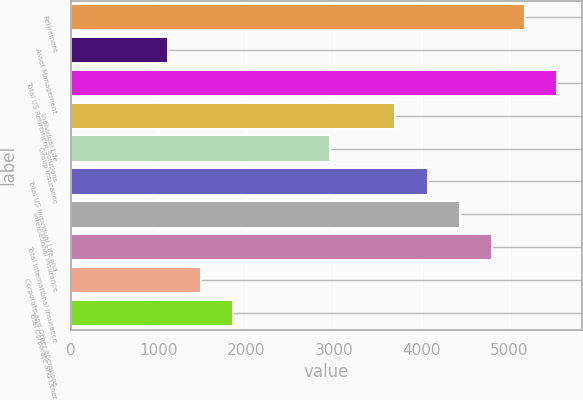<chart> <loc_0><loc_0><loc_500><loc_500><bar_chart><fcel>Retirement<fcel>Asset Management<fcel>Total US Retirement Solutions<fcel>Individual Life<fcel>Group Insurance<fcel>Total US Individual Life and<fcel>International Insurance<fcel>Total International Insurance<fcel>Corporate and Other operations<fcel>Total Corporate and Other<nl><fcel>5182.48<fcel>1111.27<fcel>5552.59<fcel>3702.04<fcel>2961.82<fcel>4072.15<fcel>4442.26<fcel>4812.37<fcel>1481.38<fcel>1851.49<nl></chart> 